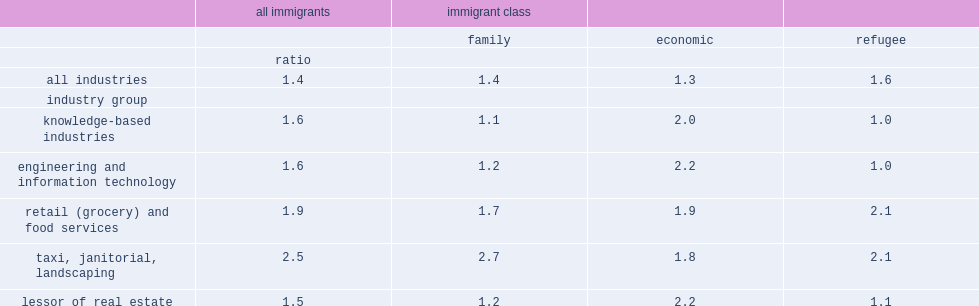Which immigrant class has the highest relative rates of primary self-employment in knowledge-based industries? Economic. Which immigrant class has the highest relative rates of primary self-employment in engineering and it industries? Economic. 